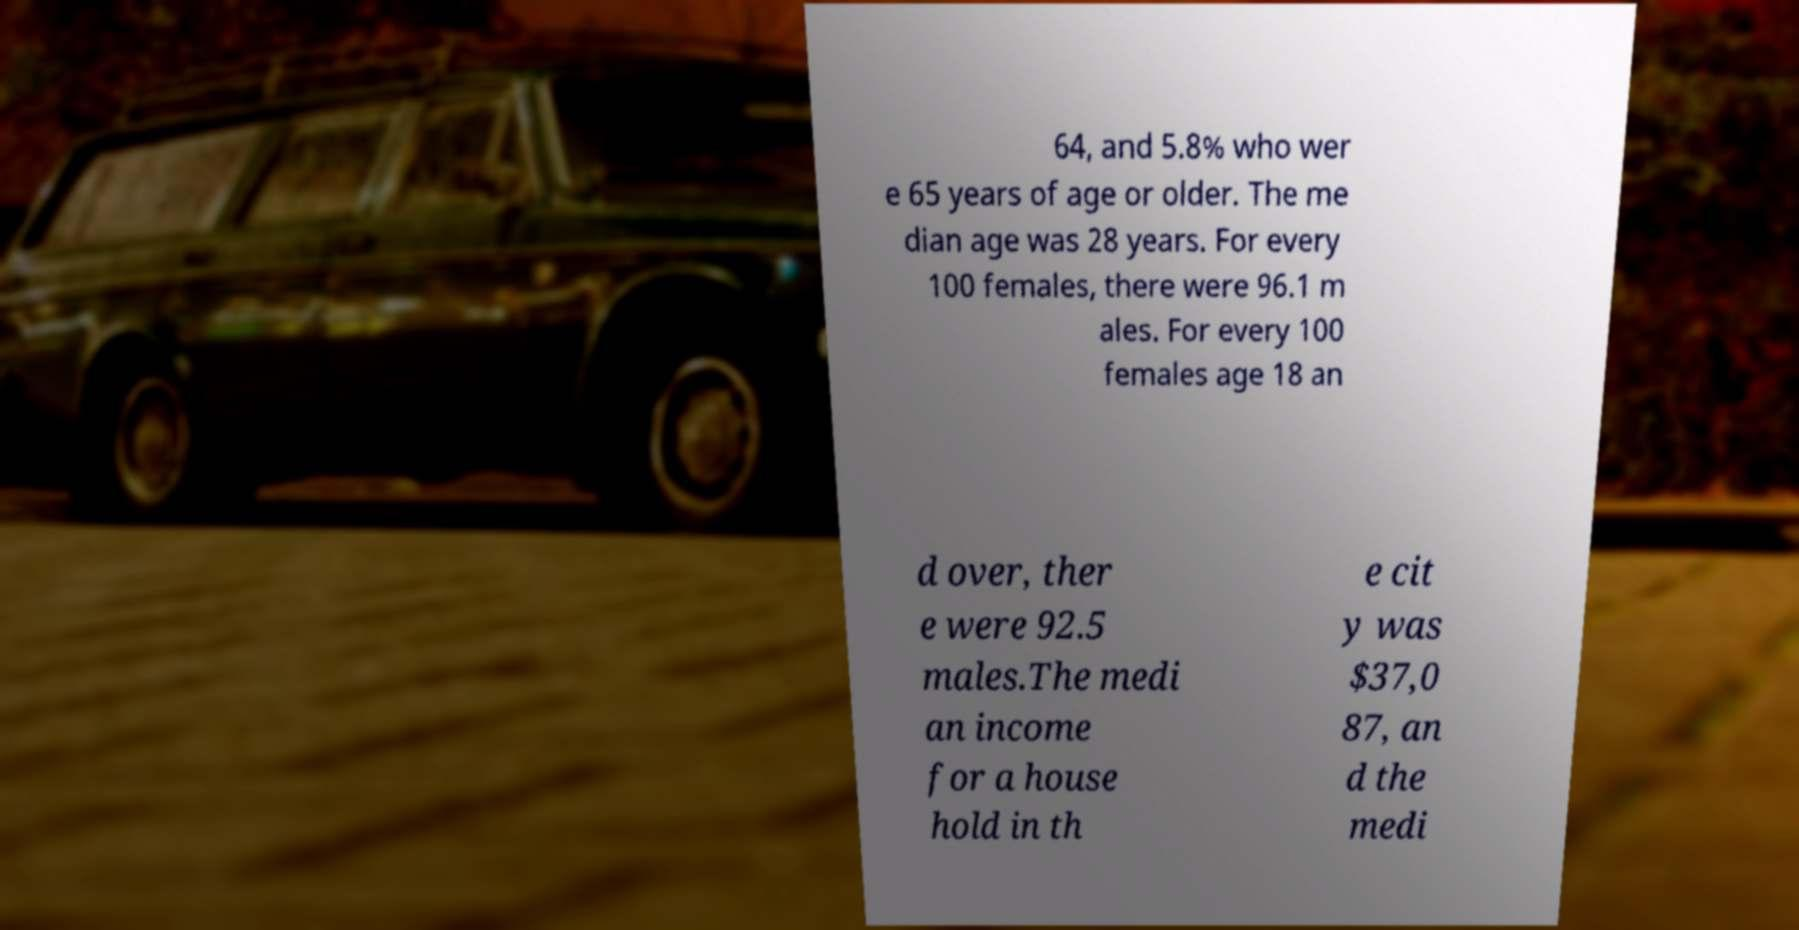Could you assist in decoding the text presented in this image and type it out clearly? 64, and 5.8% who wer e 65 years of age or older. The me dian age was 28 years. For every 100 females, there were 96.1 m ales. For every 100 females age 18 an d over, ther e were 92.5 males.The medi an income for a house hold in th e cit y was $37,0 87, an d the medi 